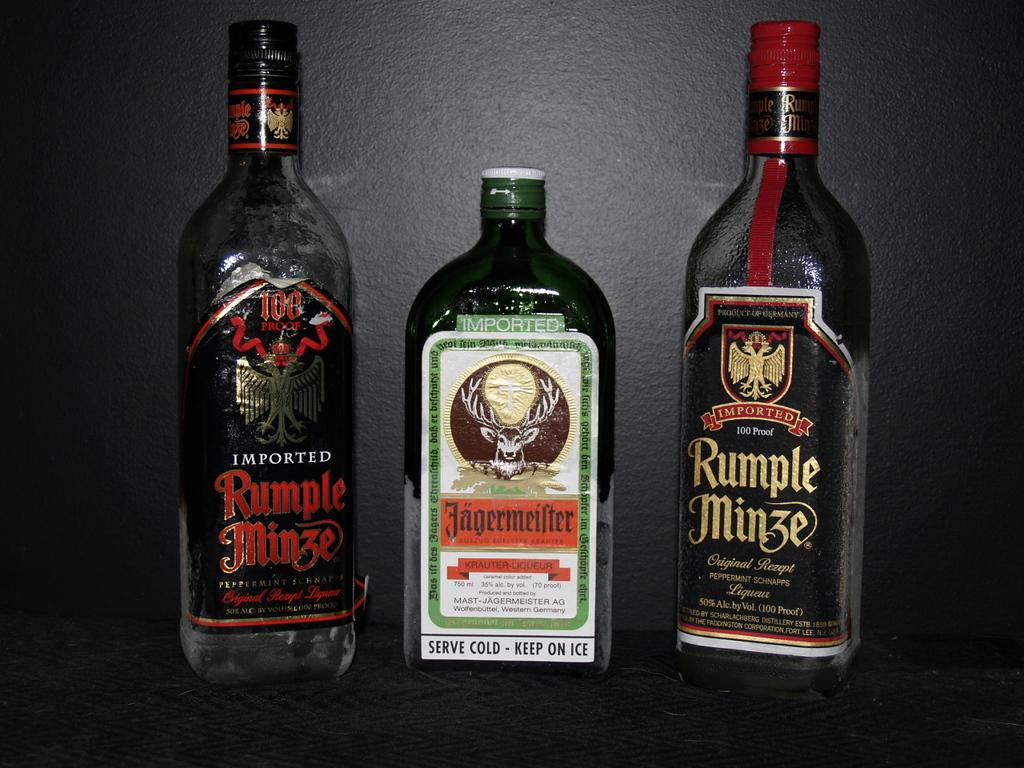Are these bottles written in german?
Ensure brevity in your answer.  Yes. 